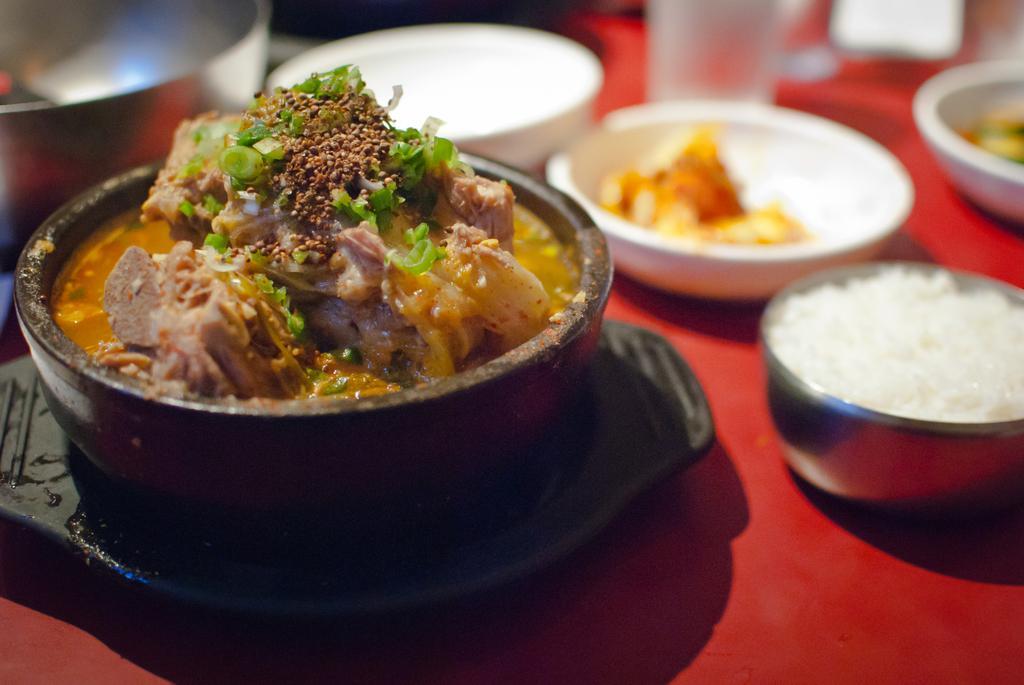Please provide a concise description of this image. In this image, we can see bowls, a glass, a plate and there are food items. At the bottom, there is a cloth on the table. 